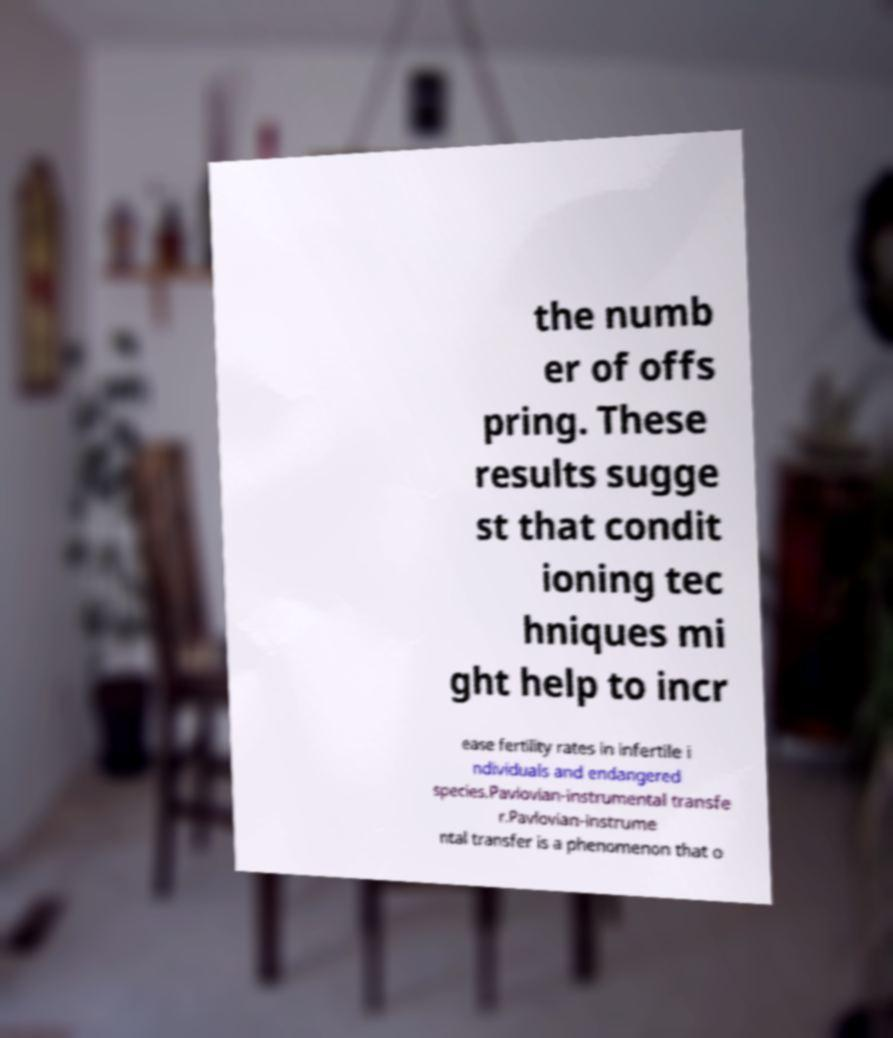Can you accurately transcribe the text from the provided image for me? the numb er of offs pring. These results sugge st that condit ioning tec hniques mi ght help to incr ease fertility rates in infertile i ndividuals and endangered species.Pavlovian-instrumental transfe r.Pavlovian-instrume ntal transfer is a phenomenon that o 